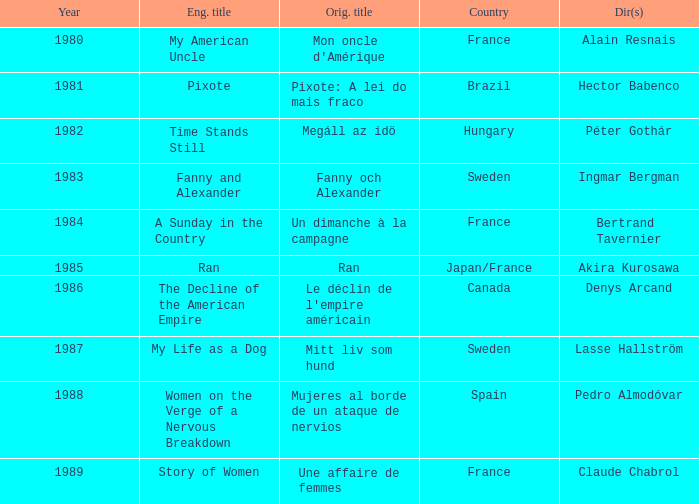What was the year of Megáll az Idö? 1982.0. 